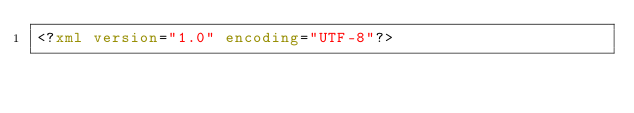<code> <loc_0><loc_0><loc_500><loc_500><_XML_><?xml version="1.0" encoding="UTF-8"?></code> 